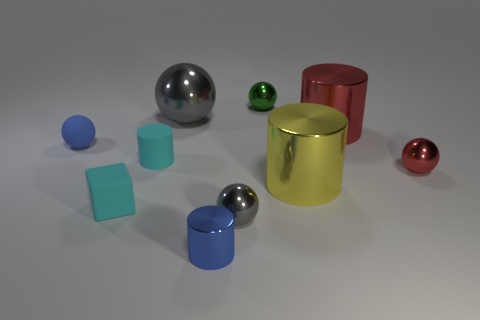What is the shape of the tiny gray thing that is the same material as the green ball? sphere 